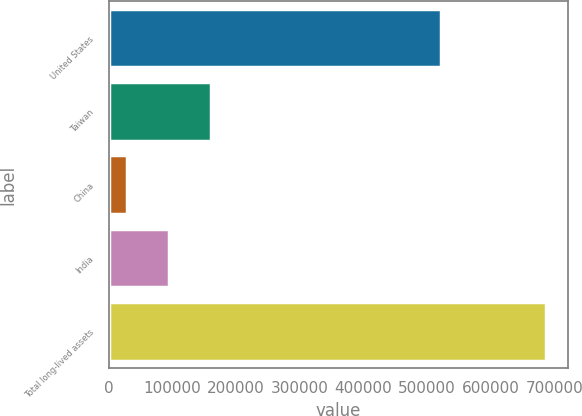<chart> <loc_0><loc_0><loc_500><loc_500><bar_chart><fcel>United States<fcel>Taiwan<fcel>China<fcel>India<fcel>Total long-lived assets<nl><fcel>522461<fcel>160849<fcel>29313<fcel>95080.9<fcel>686992<nl></chart> 